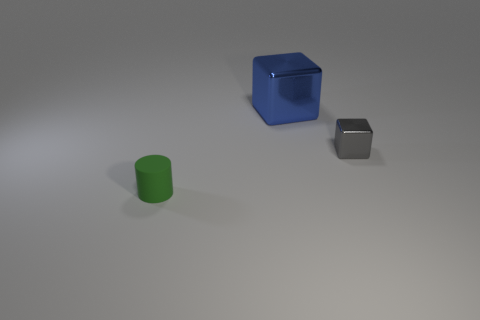Is the number of brown rubber things greater than the number of large blue cubes?
Offer a terse response. No. How many things are in front of the big cube and left of the small gray metal block?
Your answer should be compact. 1. There is a object left of the cube that is behind the shiny cube that is in front of the large cube; what shape is it?
Your answer should be compact. Cylinder. Are there any other things that are the same shape as the gray metal object?
Your answer should be very brief. Yes. How many cubes are either small green shiny things or small gray things?
Your answer should be very brief. 1. What material is the cube on the right side of the metallic object on the left side of the block in front of the blue metal object made of?
Provide a succinct answer. Metal. Is the size of the green object the same as the blue thing?
Provide a short and direct response. No. There is a thing that is made of the same material as the big block; what is its shape?
Provide a short and direct response. Cube. There is a metallic thing that is on the right side of the large thing; does it have the same shape as the tiny green object?
Your answer should be very brief. No. There is a shiny object that is left of the small object right of the cylinder; how big is it?
Your response must be concise. Large. 